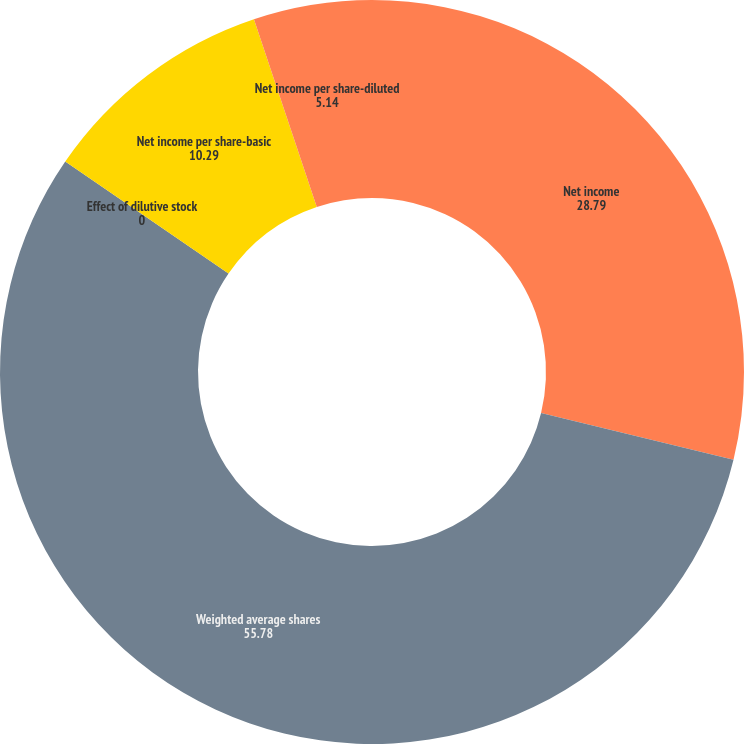Convert chart to OTSL. <chart><loc_0><loc_0><loc_500><loc_500><pie_chart><fcel>Net income<fcel>Weighted average shares<fcel>Effect of dilutive stock<fcel>Net income per share-basic<fcel>Net income per share-diluted<nl><fcel>28.79%<fcel>55.78%<fcel>0.0%<fcel>10.29%<fcel>5.14%<nl></chart> 